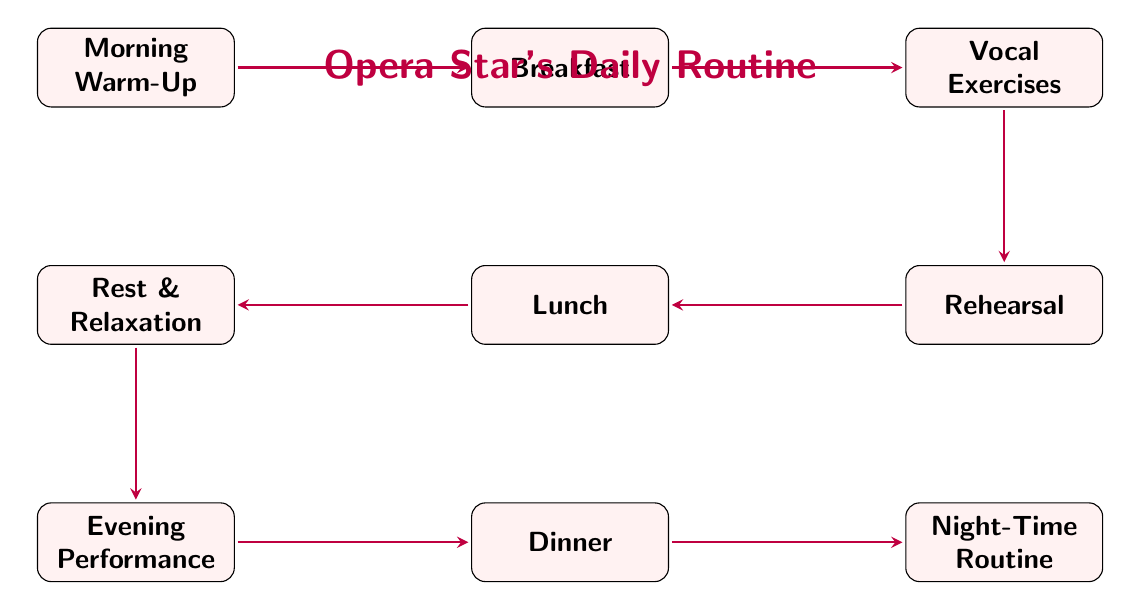What is the first node in the diagram? The first node in the diagram is indicated at the top of the flow, which is labeled "Morning Warm-Up."
Answer: Morning Warm-Up How many nodes are in the diagram? To determine the number of nodes, we can count the individual labels represented in the diagram. There are nine labels (Morning Warm-Up, Breakfast, Vocal Exercises, Rehearsal, Lunch, Rest & Relaxation, Evening Performance, Dinner, Night-Time Routine).
Answer: 9 What is the last node in the flow? The last node in the flow diagram can be identified as the one positioned furthest right at the bottom. It is labeled "Night-Time Routine."
Answer: Night-Time Routine Which two nodes are directly connected after Breakfast? The nodes that are directly connected after Breakfast can be found in the flow: Breakfast is followed by Vocal Exercises.
Answer: Vocal Exercises What activity comes before the Evening Performance? To find the activity before the Evening Performance, we look at the node directly above it in the flow. This node is labeled "Rest & Relaxation."
Answer: Rest & Relaxation How many edges connect to Rehearsal? Rehearsal has edges connecting it to Vocal Exercises before it, and Lunch after it. This results in a total of two edges.
Answer: 2 Which meal is planned after Lunch? The flow connects directly from Lunch to Rest & Relaxation, but it can be observed that the next meal after Lunch, if looking at the evening activities, would be Dinner.
Answer: Dinner Which activity occurs immediately after Vocal Exercises? To find the activity that follows Vocal Exercises, we look at the next node in the flow, which is labeled "Rehearsal."
Answer: Rehearsal What is the relationship between Breakfast and Lunch? In the diagram, the relationship indicates that Breakfast leads directly into the node for Vocal Exercises, followed subsequently by Rehearsal, which then connects to Lunch, showing a sequential connection in the daily routine.
Answer: Breakfast leads to Lunch through Vocal Exercises and Rehearsal 